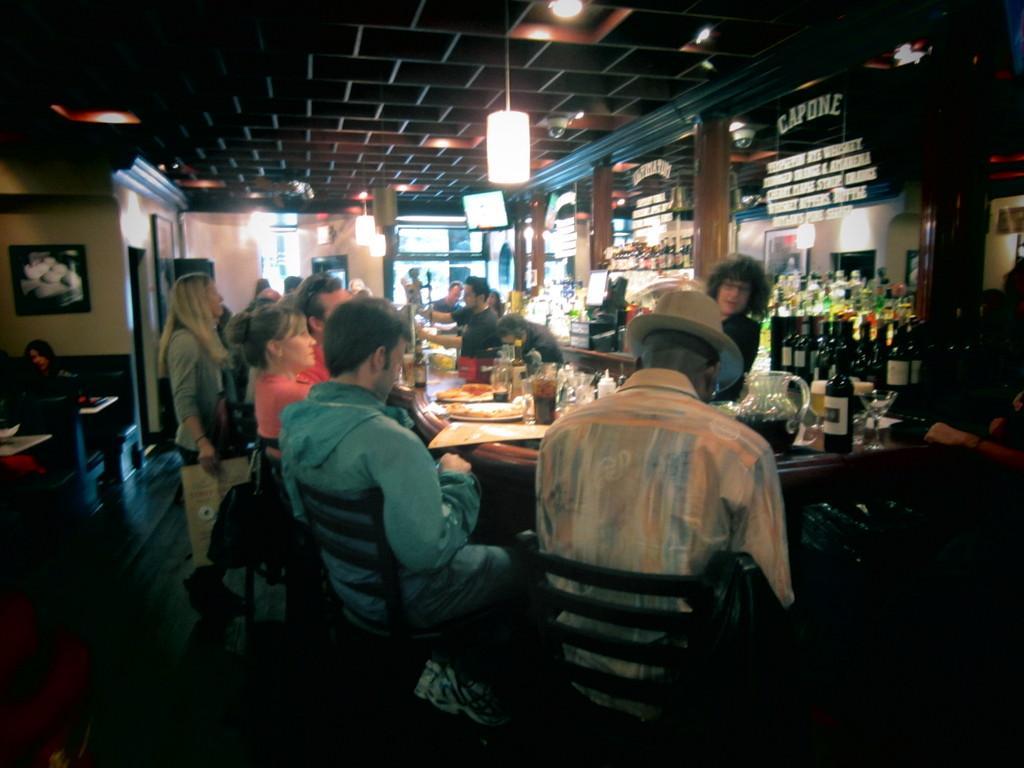Please provide a concise description of this image. In the image we can see there are many people standing and some are sitting. They are wearing clothes and this person is wearing hat. There is a table, on the table there is a jug, bottle, glass, plant and food on a plate. These are the lights, floor, frame, wall and a window. 